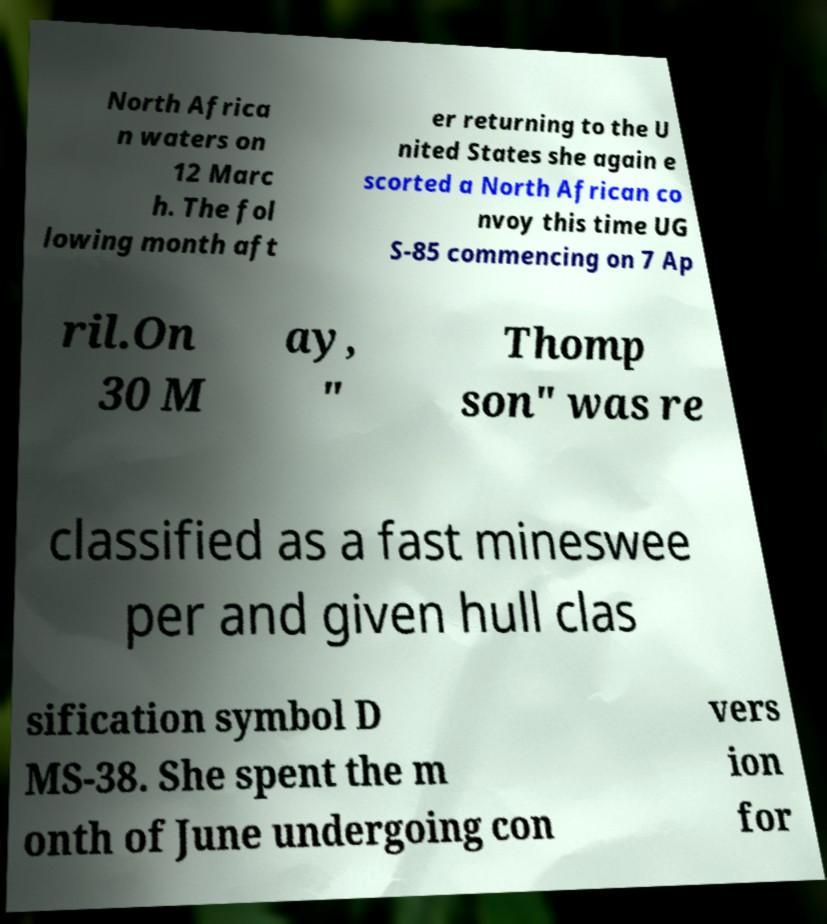Could you extract and type out the text from this image? North Africa n waters on 12 Marc h. The fol lowing month aft er returning to the U nited States she again e scorted a North African co nvoy this time UG S-85 commencing on 7 Ap ril.On 30 M ay, " Thomp son" was re classified as a fast mineswee per and given hull clas sification symbol D MS-38. She spent the m onth of June undergoing con vers ion for 